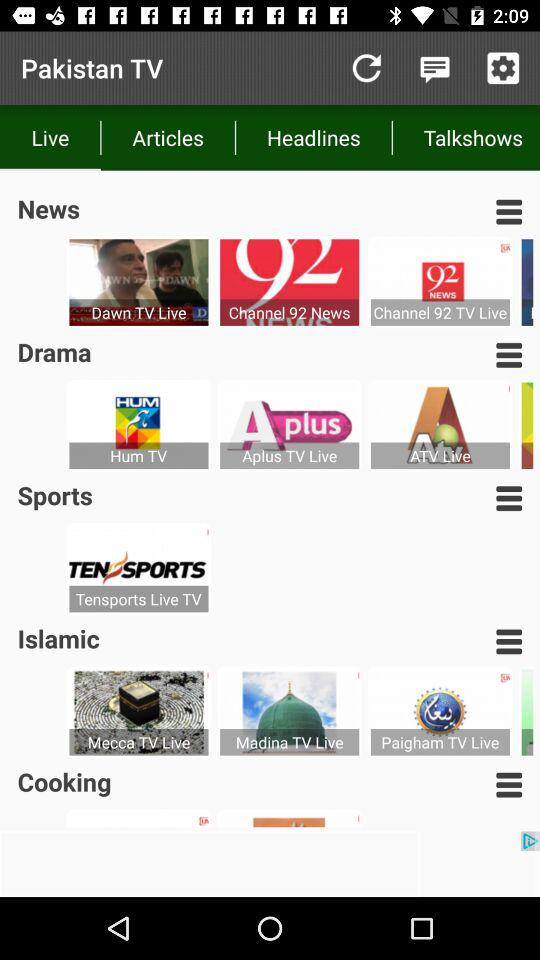What type of channel is "Hum TV"? The type of channel is drama. 